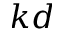Convert formula to latex. <formula><loc_0><loc_0><loc_500><loc_500>k d</formula> 